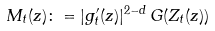Convert formula to latex. <formula><loc_0><loc_0><loc_500><loc_500>M _ { t } ( z ) \colon = | g _ { t } ^ { \prime } ( z ) | ^ { 2 - d } \, G ( Z _ { t } ( z ) )</formula> 